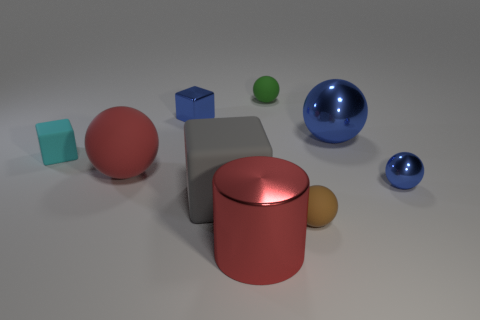Is there a big red shiny cylinder?
Your answer should be very brief. Yes. Are there more gray things in front of the big red cylinder than blue spheres behind the shiny cube?
Provide a succinct answer. No. What is the material of the thing that is both right of the small blue metallic block and left of the red metallic cylinder?
Your response must be concise. Rubber. Is the red shiny object the same shape as the tiny cyan object?
Your answer should be very brief. No. Is there any other thing that is the same size as the gray rubber thing?
Your response must be concise. Yes. How many gray matte objects are in front of the small brown thing?
Your response must be concise. 0. There is a matte block that is to the right of the metallic block; does it have the same size as the tiny brown rubber sphere?
Provide a short and direct response. No. What is the color of the other tiny metal thing that is the same shape as the green object?
Keep it short and to the point. Blue. Is there anything else that has the same shape as the gray matte thing?
Provide a short and direct response. Yes. There is a small object that is in front of the big gray thing; what is its shape?
Offer a very short reply. Sphere. 